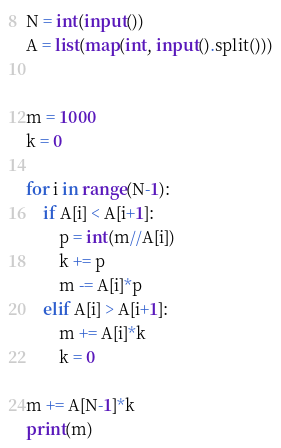Convert code to text. <code><loc_0><loc_0><loc_500><loc_500><_Python_>N = int(input())
A = list(map(int, input().split()))


m = 1000
k = 0

for i in range(N-1):
    if A[i] < A[i+1]:
        p = int(m//A[i])
        k += p
        m -= A[i]*p
    elif A[i] > A[i+1]:
        m += A[i]*k
        k = 0

m += A[N-1]*k
print(m)</code> 